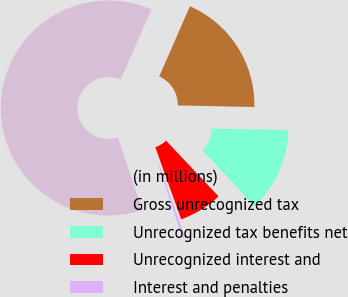<chart> <loc_0><loc_0><loc_500><loc_500><pie_chart><fcel>(in millions)<fcel>Gross unrecognized tax<fcel>Unrecognized tax benefits net<fcel>Unrecognized interest and<fcel>Interest and penalties<nl><fcel>61.64%<fcel>18.78%<fcel>12.65%<fcel>6.53%<fcel>0.4%<nl></chart> 